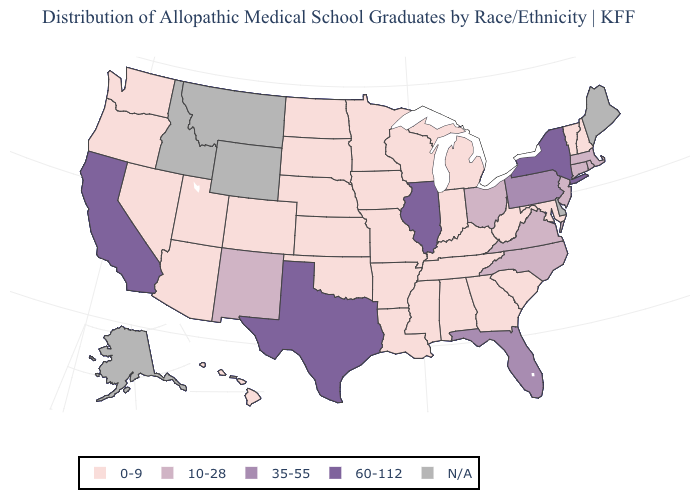Does Illinois have the highest value in the USA?
Be succinct. Yes. Name the states that have a value in the range 60-112?
Write a very short answer. California, Illinois, New York, Texas. Which states hav the highest value in the West?
Write a very short answer. California. What is the highest value in the MidWest ?
Write a very short answer. 60-112. What is the value of Arkansas?
Keep it brief. 0-9. What is the value of New Mexico?
Concise answer only. 10-28. What is the highest value in states that border Nevada?
Keep it brief. 60-112. Is the legend a continuous bar?
Quick response, please. No. Among the states that border New York , which have the highest value?
Answer briefly. Pennsylvania. What is the value of Louisiana?
Be succinct. 0-9. Does Georgia have the lowest value in the South?
Quick response, please. Yes. What is the value of Connecticut?
Keep it brief. 10-28. Does the first symbol in the legend represent the smallest category?
Keep it brief. Yes. What is the value of Tennessee?
Answer briefly. 0-9. 